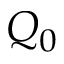<formula> <loc_0><loc_0><loc_500><loc_500>Q _ { 0 }</formula> 